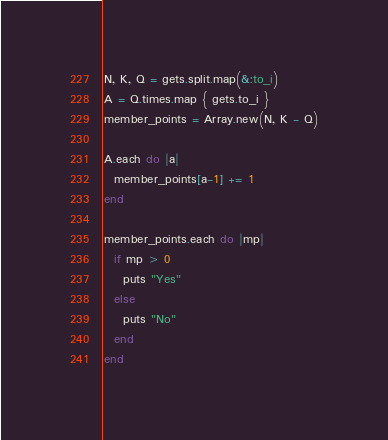<code> <loc_0><loc_0><loc_500><loc_500><_Ruby_>N, K, Q = gets.split.map(&:to_i)
A = Q.times.map { gets.to_i }
member_points = Array.new(N, K - Q)

A.each do |a|
  member_points[a-1] += 1
end

member_points.each do |mp|
  if mp > 0
    puts "Yes"
  else
    puts "No"
  end
end
</code> 